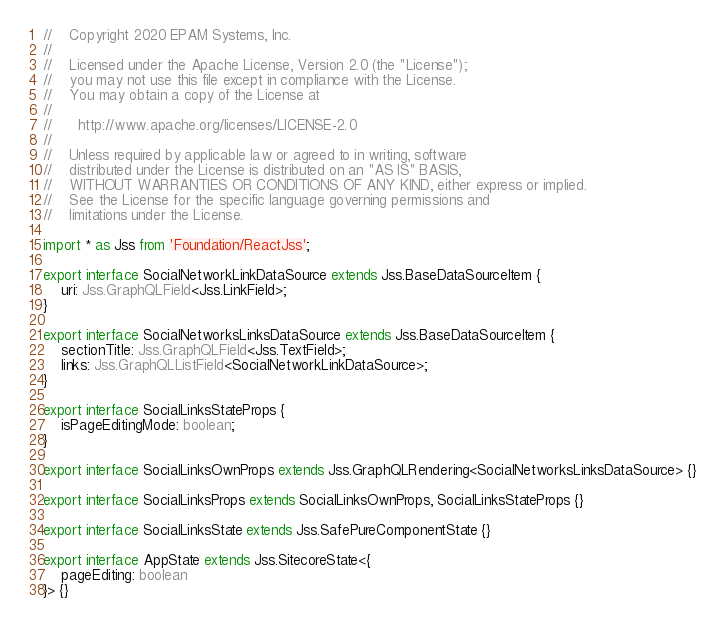<code> <loc_0><loc_0><loc_500><loc_500><_TypeScript_>//    Copyright 2020 EPAM Systems, Inc.
// 
//    Licensed under the Apache License, Version 2.0 (the "License");
//    you may not use this file except in compliance with the License.
//    You may obtain a copy of the License at
// 
//      http://www.apache.org/licenses/LICENSE-2.0
// 
//    Unless required by applicable law or agreed to in writing, software
//    distributed under the License is distributed on an "AS IS" BASIS,
//    WITHOUT WARRANTIES OR CONDITIONS OF ANY KIND, either express or implied.
//    See the License for the specific language governing permissions and
//    limitations under the License.

import * as Jss from 'Foundation/ReactJss';

export interface SocialNetworkLinkDataSource extends Jss.BaseDataSourceItem {
    uri: Jss.GraphQLField<Jss.LinkField>;
}

export interface SocialNetworksLinksDataSource extends Jss.BaseDataSourceItem {
    sectionTitle: Jss.GraphQLField<Jss.TextField>;
    links: Jss.GraphQLListField<SocialNetworkLinkDataSource>;
}

export interface SocialLinksStateProps {
    isPageEditingMode: boolean;
}

export interface SocialLinksOwnProps extends Jss.GraphQLRendering<SocialNetworksLinksDataSource> {}

export interface SocialLinksProps extends SocialLinksOwnProps, SocialLinksStateProps {}

export interface SocialLinksState extends Jss.SafePureComponentState {}

export interface AppState extends Jss.SitecoreState<{
    pageEditing: boolean
}> {}
</code> 